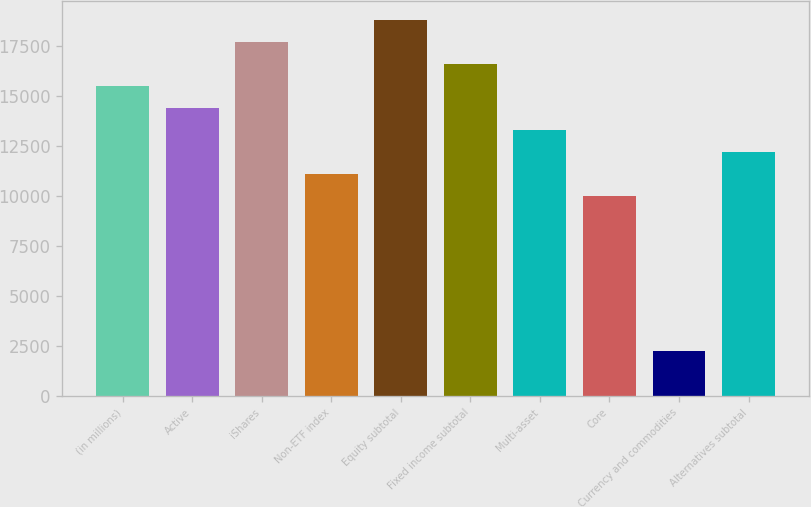Convert chart. <chart><loc_0><loc_0><loc_500><loc_500><bar_chart><fcel>(in millions)<fcel>Active<fcel>iShares<fcel>Non-ETF index<fcel>Equity subtotal<fcel>Fixed income subtotal<fcel>Multi-asset<fcel>Core<fcel>Currency and commodities<fcel>Alternatives subtotal<nl><fcel>15501<fcel>14396<fcel>17711<fcel>11081<fcel>18816<fcel>16606<fcel>13291<fcel>9976<fcel>2241<fcel>12186<nl></chart> 